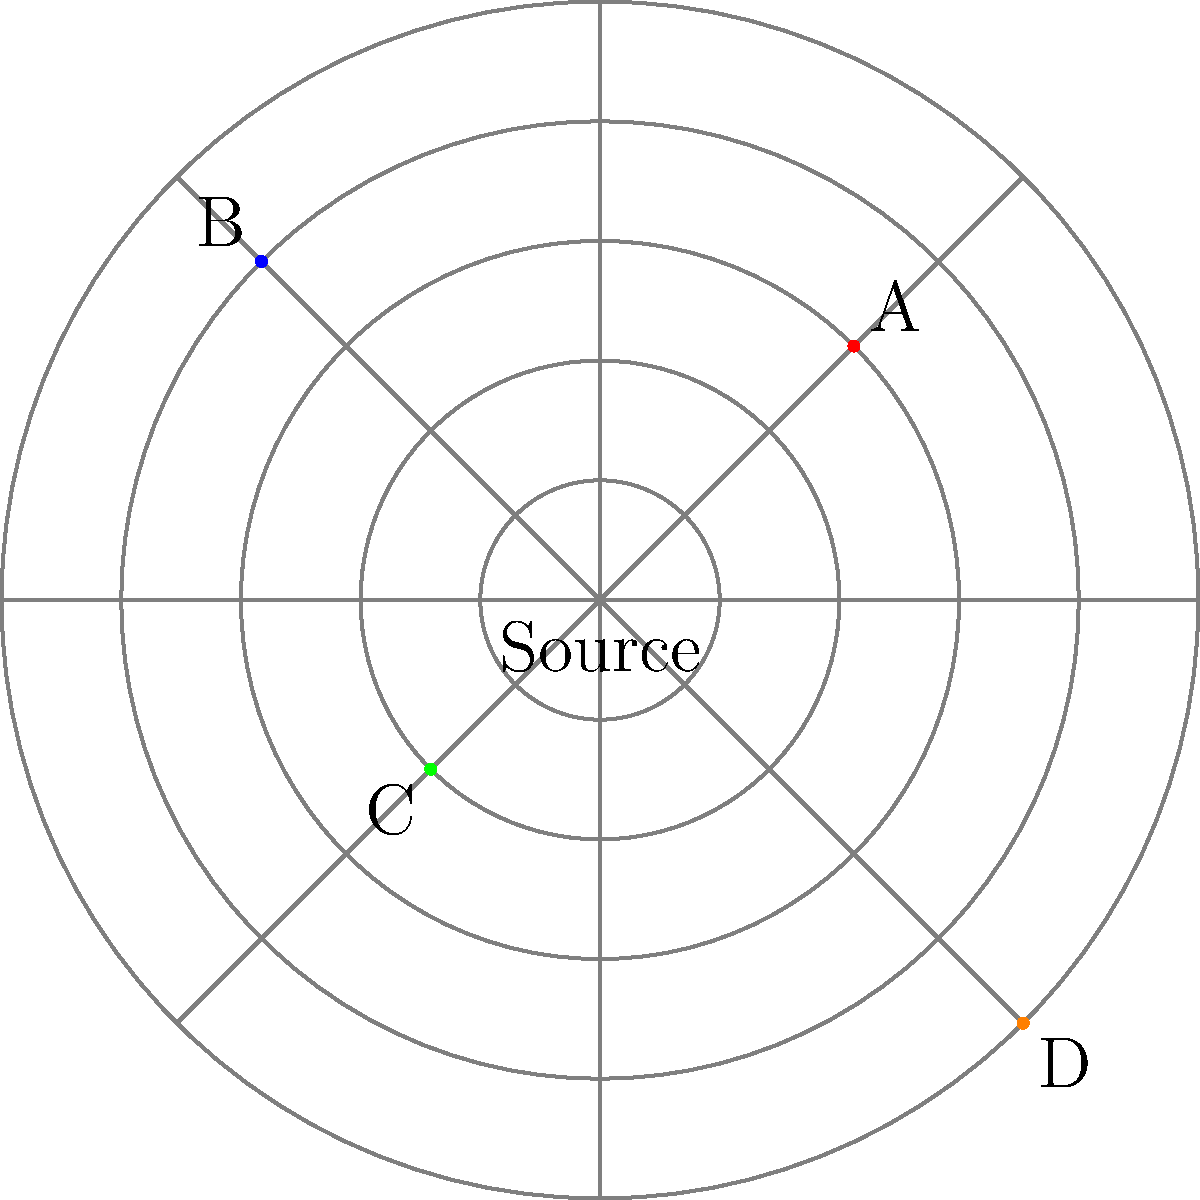In the polar coordinate system shown, representing the spread of pirated copies of your latest novel from a single source, which location indicates the farthest reach of piracy with the least angular deviation from the positive x-axis? To solve this problem, we need to analyze the polar coordinates of each point:

1. Understand the polar coordinate system:
   - The radial coordinate (r) represents the distance from the origin.
   - The angular coordinate (θ) represents the angle from the positive x-axis.

2. Identify the coordinates of each point:
   A: (r = 3, θ = π/4)
   B: (r = 4, θ = 3π/4)
   C: (r = 2, θ = 5π/4)
   D: (r = 5, θ = 7π/4)

3. Compare the radial coordinates:
   D has the largest r-value (5), indicating the farthest reach.

4. Compare the angular coordinates:
   A: π/4 ≈ 0.79 radians
   B: 3π/4 ≈ 2.36 radians
   C: 5π/4 ≈ 3.93 radians
   D: 7π/4 ≈ 5.50 radians

5. Determine which angle is closest to 0 (positive x-axis):
   A has the smallest angle (π/4), closest to the positive x-axis.

6. Conclusion:
   Point D has the farthest reach (r = 5) and the second-smallest angular deviation from the positive x-axis (7π/4).

Therefore, location D indicates the farthest reach of piracy with the least angular deviation from the positive x-axis.
Answer: D 